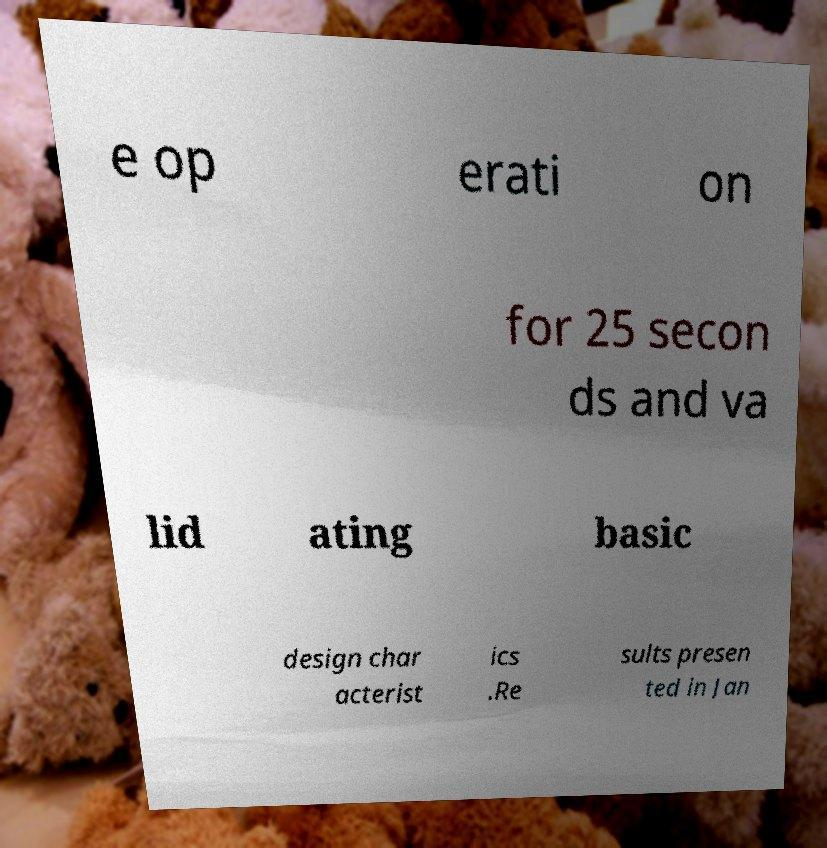Please identify and transcribe the text found in this image. e op erati on for 25 secon ds and va lid ating basic design char acterist ics .Re sults presen ted in Jan 